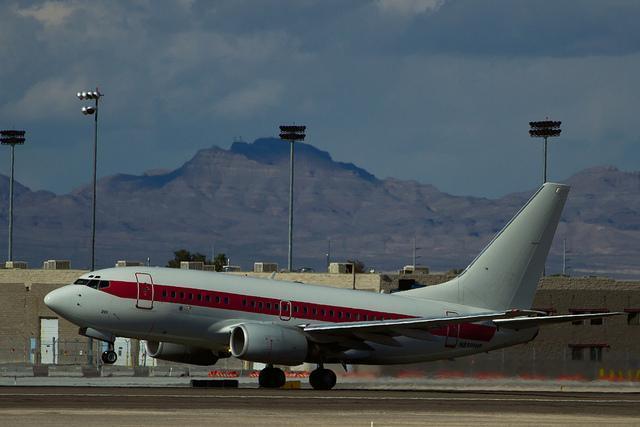How many KLM planes can you spot?
Give a very brief answer. 1. How many plans are taking off?
Give a very brief answer. 1. How many planes are there?
Give a very brief answer. 1. How many of the fruit that can be seen in the bowl are bananas?
Give a very brief answer. 0. 